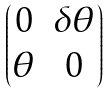Convert formula to latex. <formula><loc_0><loc_0><loc_500><loc_500>\begin{pmatrix} 0 & \delta \theta \\ \theta & 0 \end{pmatrix}</formula> 